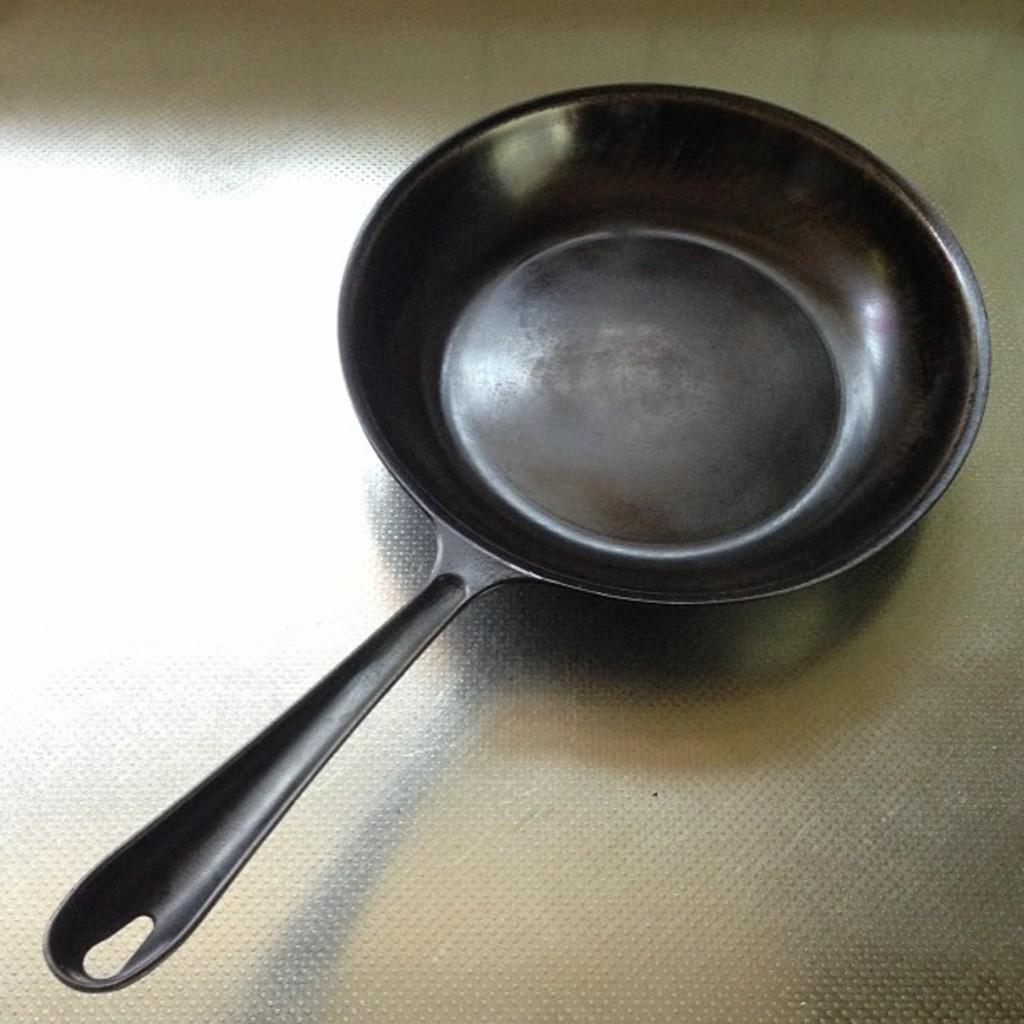What is the color of the pan in the image? The pan in the image is black. Where is the black pan located? The black pan is placed on a table. How does the pan shake in the image? The pan does not shake in the image; it is stationary on the table. What type of ear is visible on the pan in the image? There is no ear present on the pan in the image, as it is an inanimate object. 